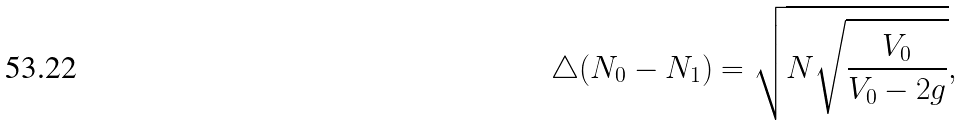<formula> <loc_0><loc_0><loc_500><loc_500>\triangle ( N _ { 0 } - N _ { 1 } ) = \sqrt { N \sqrt { \frac { V _ { 0 } } { V _ { 0 } - 2 g } } } ,</formula> 